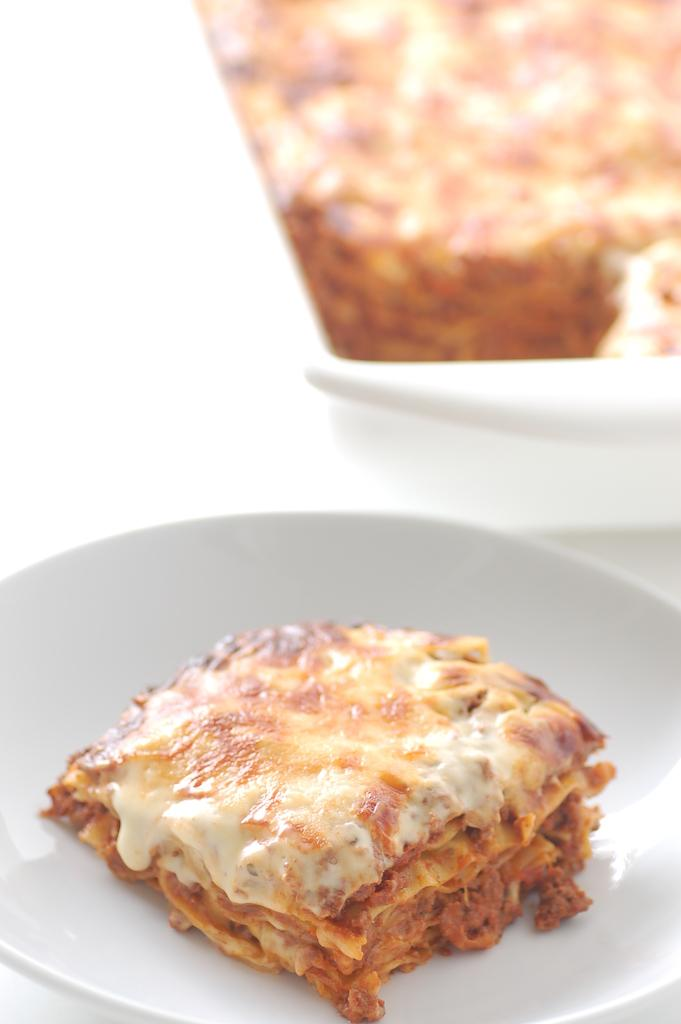What is present on the plate in the image? There is food on the plate in the image. Can you describe the plate in the image? The plate is the main object in the image, and it is holding the food. What type of book is placed on the plate in the image? There is no book present on the plate in the image; it only contains food. 